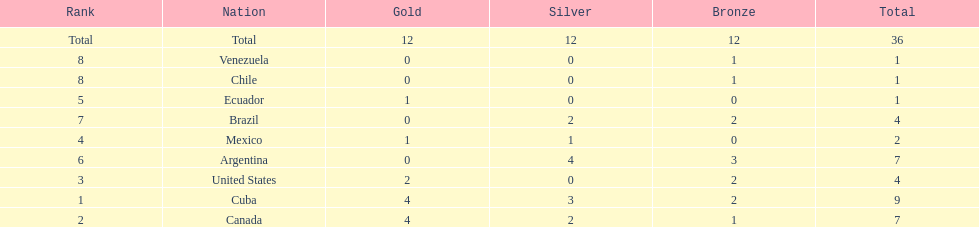Which ranking is mexico? 4. 